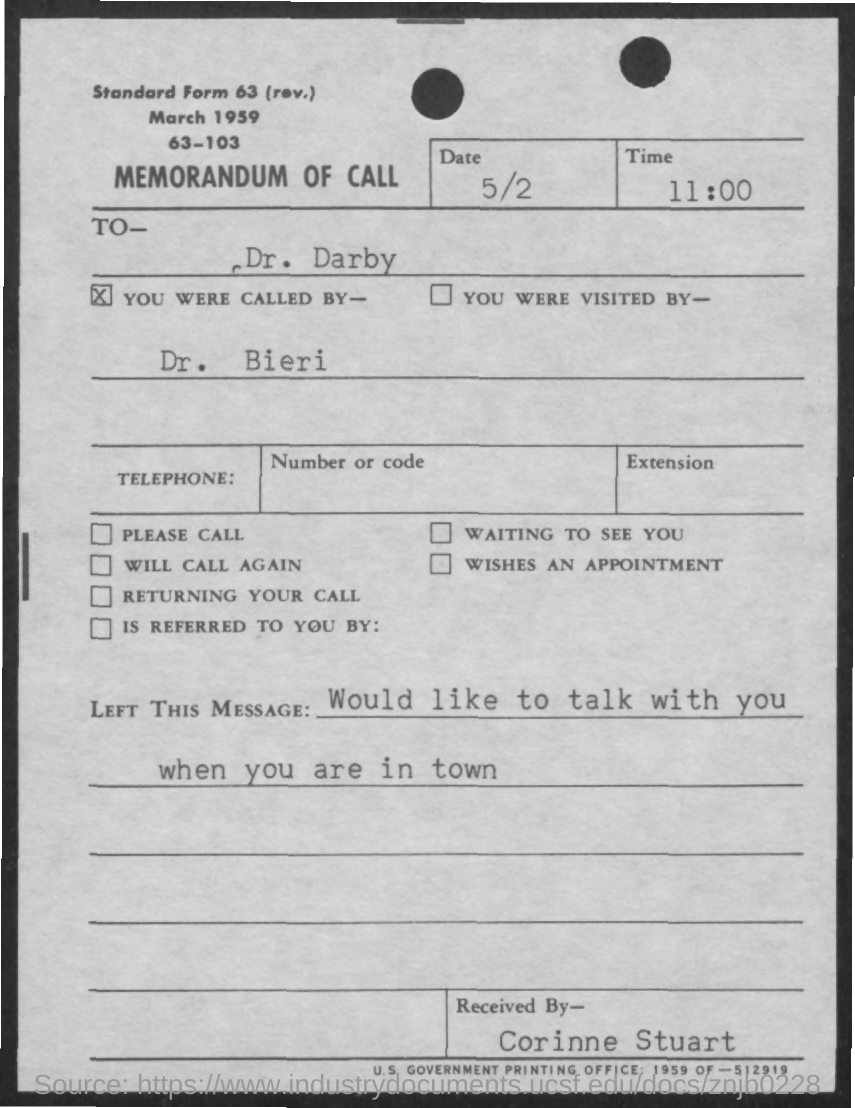Point out several critical features in this image. Dr. Darby was called by Dr. Bieri. The document is addressed to Dr. Darby. The title of the document is 'Memorandum of Call'. The message was that the person would like to talk with the recipient when they are in town. It is known that the recipient of the call was Corinne Stuart. 